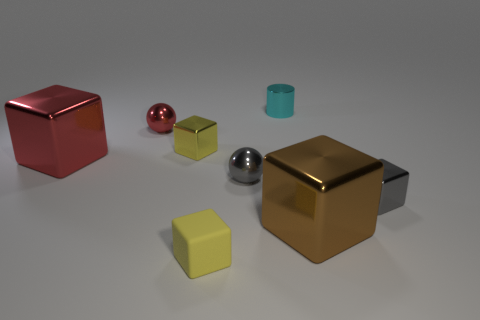Add 1 spheres. How many objects exist? 9 Subtract all yellow cubes. How many cubes are left? 3 Subtract 1 cylinders. How many cylinders are left? 0 Subtract all cylinders. How many objects are left? 7 Subtract all purple balls. How many red cubes are left? 1 Subtract all large brown shiny cylinders. Subtract all small rubber things. How many objects are left? 7 Add 4 tiny cylinders. How many tiny cylinders are left? 5 Add 4 big green shiny blocks. How many big green shiny blocks exist? 4 Subtract all red blocks. How many blocks are left? 4 Subtract 0 green cylinders. How many objects are left? 8 